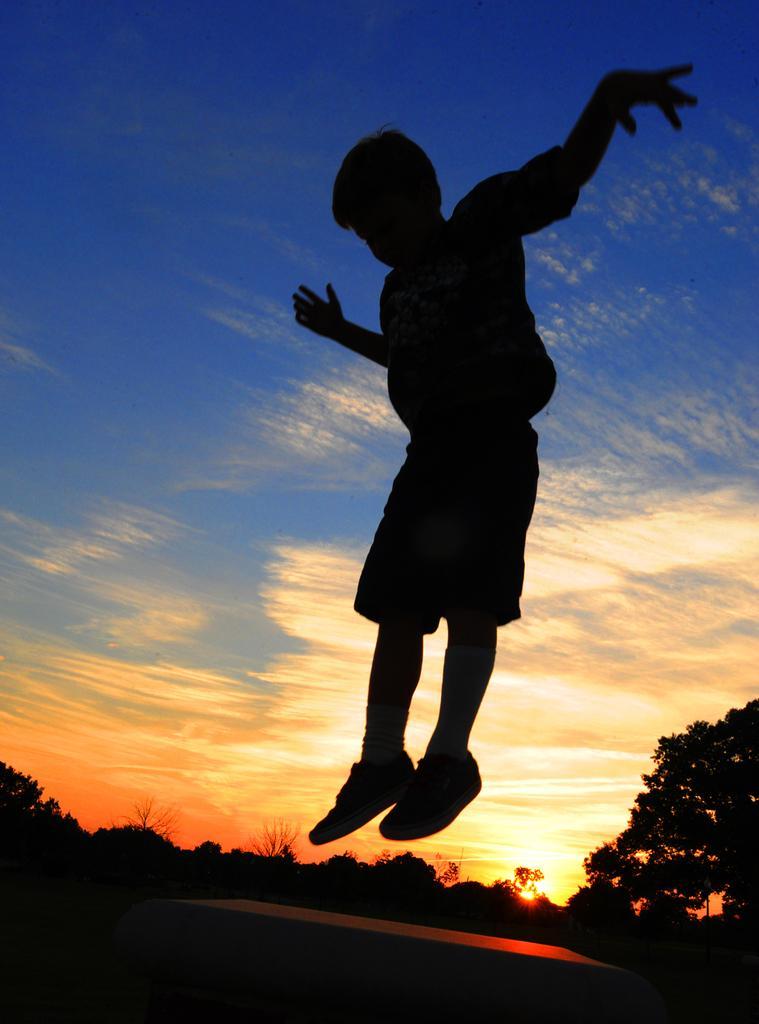Can you describe this image briefly? In this picture there is a boy jumping. At the bottom there is an object. At the back there are trees. At the top there is sky and there are clouds and there is a sun. 